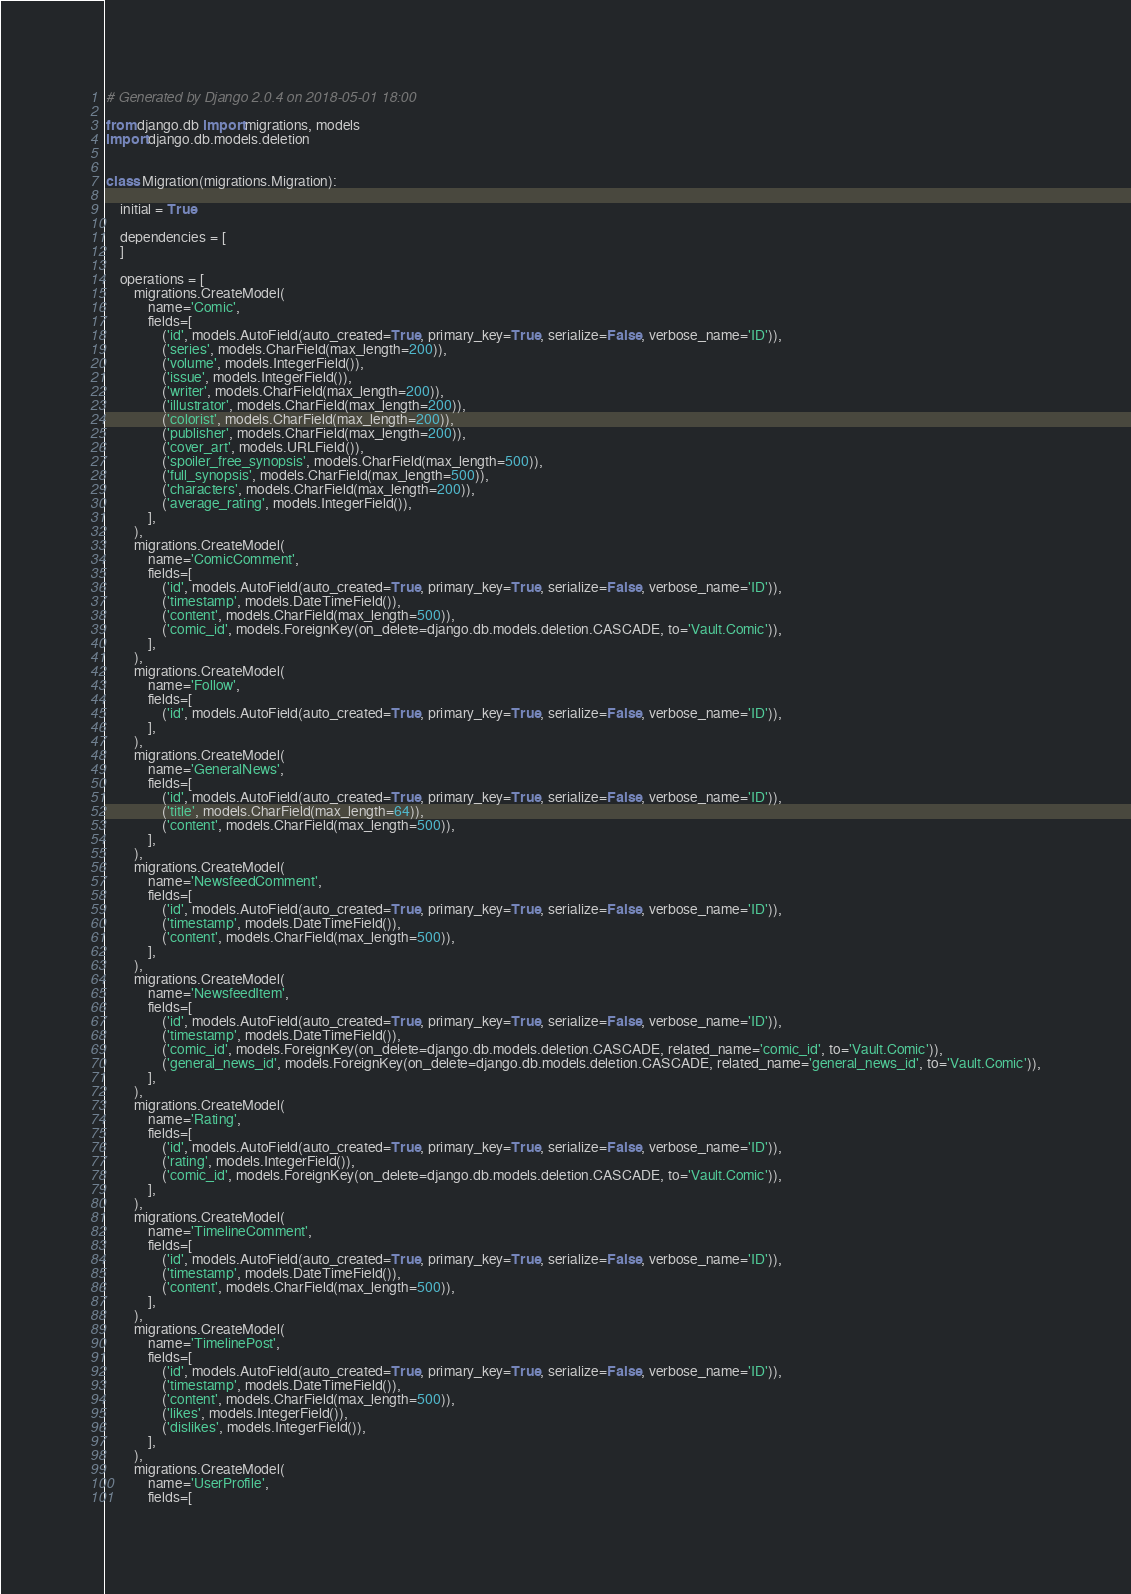<code> <loc_0><loc_0><loc_500><loc_500><_Python_># Generated by Django 2.0.4 on 2018-05-01 18:00

from django.db import migrations, models
import django.db.models.deletion


class Migration(migrations.Migration):

    initial = True

    dependencies = [
    ]

    operations = [
        migrations.CreateModel(
            name='Comic',
            fields=[
                ('id', models.AutoField(auto_created=True, primary_key=True, serialize=False, verbose_name='ID')),
                ('series', models.CharField(max_length=200)),
                ('volume', models.IntegerField()),
                ('issue', models.IntegerField()),
                ('writer', models.CharField(max_length=200)),
                ('illustrator', models.CharField(max_length=200)),
                ('colorist', models.CharField(max_length=200)),
                ('publisher', models.CharField(max_length=200)),
                ('cover_art', models.URLField()),
                ('spoiler_free_synopsis', models.CharField(max_length=500)),
                ('full_synopsis', models.CharField(max_length=500)),
                ('characters', models.CharField(max_length=200)),
                ('average_rating', models.IntegerField()),
            ],
        ),
        migrations.CreateModel(
            name='ComicComment',
            fields=[
                ('id', models.AutoField(auto_created=True, primary_key=True, serialize=False, verbose_name='ID')),
                ('timestamp', models.DateTimeField()),
                ('content', models.CharField(max_length=500)),
                ('comic_id', models.ForeignKey(on_delete=django.db.models.deletion.CASCADE, to='Vault.Comic')),
            ],
        ),
        migrations.CreateModel(
            name='Follow',
            fields=[
                ('id', models.AutoField(auto_created=True, primary_key=True, serialize=False, verbose_name='ID')),
            ],
        ),
        migrations.CreateModel(
            name='GeneralNews',
            fields=[
                ('id', models.AutoField(auto_created=True, primary_key=True, serialize=False, verbose_name='ID')),
                ('title', models.CharField(max_length=64)),
                ('content', models.CharField(max_length=500)),
            ],
        ),
        migrations.CreateModel(
            name='NewsfeedComment',
            fields=[
                ('id', models.AutoField(auto_created=True, primary_key=True, serialize=False, verbose_name='ID')),
                ('timestamp', models.DateTimeField()),
                ('content', models.CharField(max_length=500)),
            ],
        ),
        migrations.CreateModel(
            name='NewsfeedItem',
            fields=[
                ('id', models.AutoField(auto_created=True, primary_key=True, serialize=False, verbose_name='ID')),
                ('timestamp', models.DateTimeField()),
                ('comic_id', models.ForeignKey(on_delete=django.db.models.deletion.CASCADE, related_name='comic_id', to='Vault.Comic')),
                ('general_news_id', models.ForeignKey(on_delete=django.db.models.deletion.CASCADE, related_name='general_news_id', to='Vault.Comic')),
            ],
        ),
        migrations.CreateModel(
            name='Rating',
            fields=[
                ('id', models.AutoField(auto_created=True, primary_key=True, serialize=False, verbose_name='ID')),
                ('rating', models.IntegerField()),
                ('comic_id', models.ForeignKey(on_delete=django.db.models.deletion.CASCADE, to='Vault.Comic')),
            ],
        ),
        migrations.CreateModel(
            name='TimelineComment',
            fields=[
                ('id', models.AutoField(auto_created=True, primary_key=True, serialize=False, verbose_name='ID')),
                ('timestamp', models.DateTimeField()),
                ('content', models.CharField(max_length=500)),
            ],
        ),
        migrations.CreateModel(
            name='TimelinePost',
            fields=[
                ('id', models.AutoField(auto_created=True, primary_key=True, serialize=False, verbose_name='ID')),
                ('timestamp', models.DateTimeField()),
                ('content', models.CharField(max_length=500)),
                ('likes', models.IntegerField()),
                ('dislikes', models.IntegerField()),
            ],
        ),
        migrations.CreateModel(
            name='UserProfile',
            fields=[</code> 